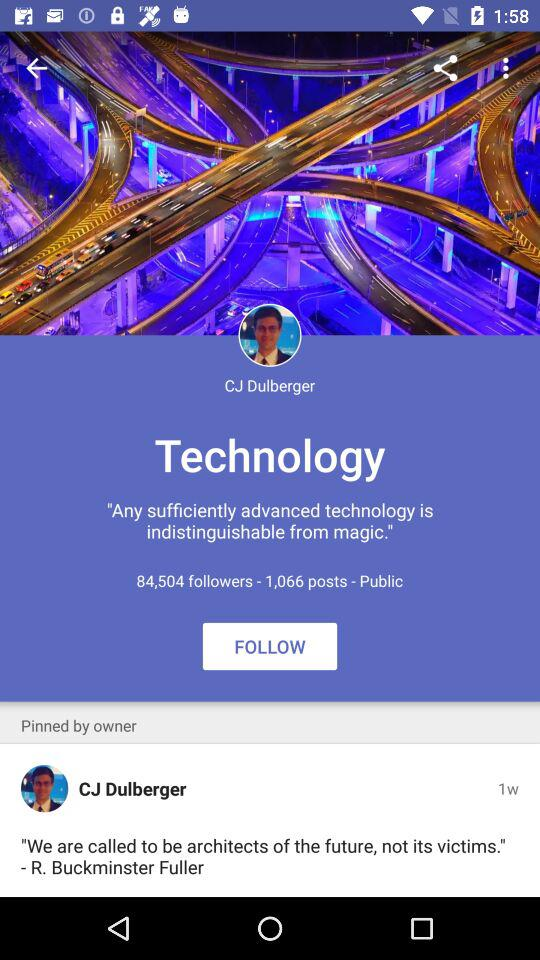How many people are following CJ Dulberger?
Answer the question using a single word or phrase. 84,504 